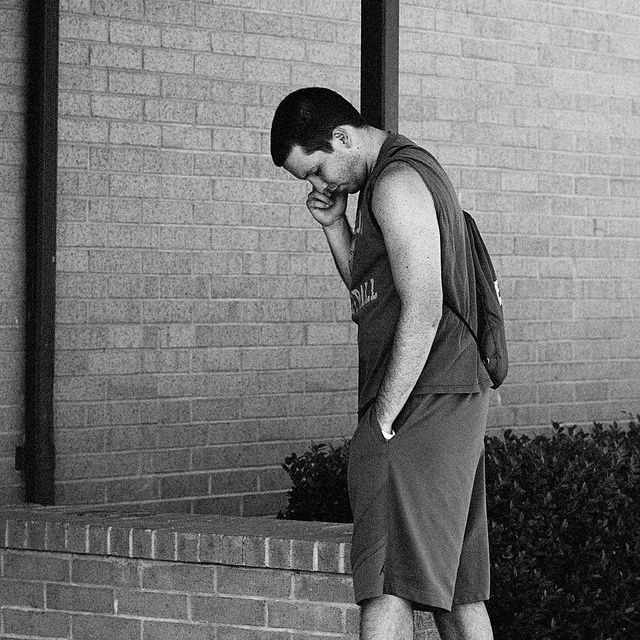Describe the objects in this image and their specific colors. I can see people in gray, black, darkgray, and lightgray tones, backpack in gray, black, darkgray, and lightgray tones, handbag in gray, black, darkgray, and lightgray tones, and cell phone in gray and black tones in this image. 